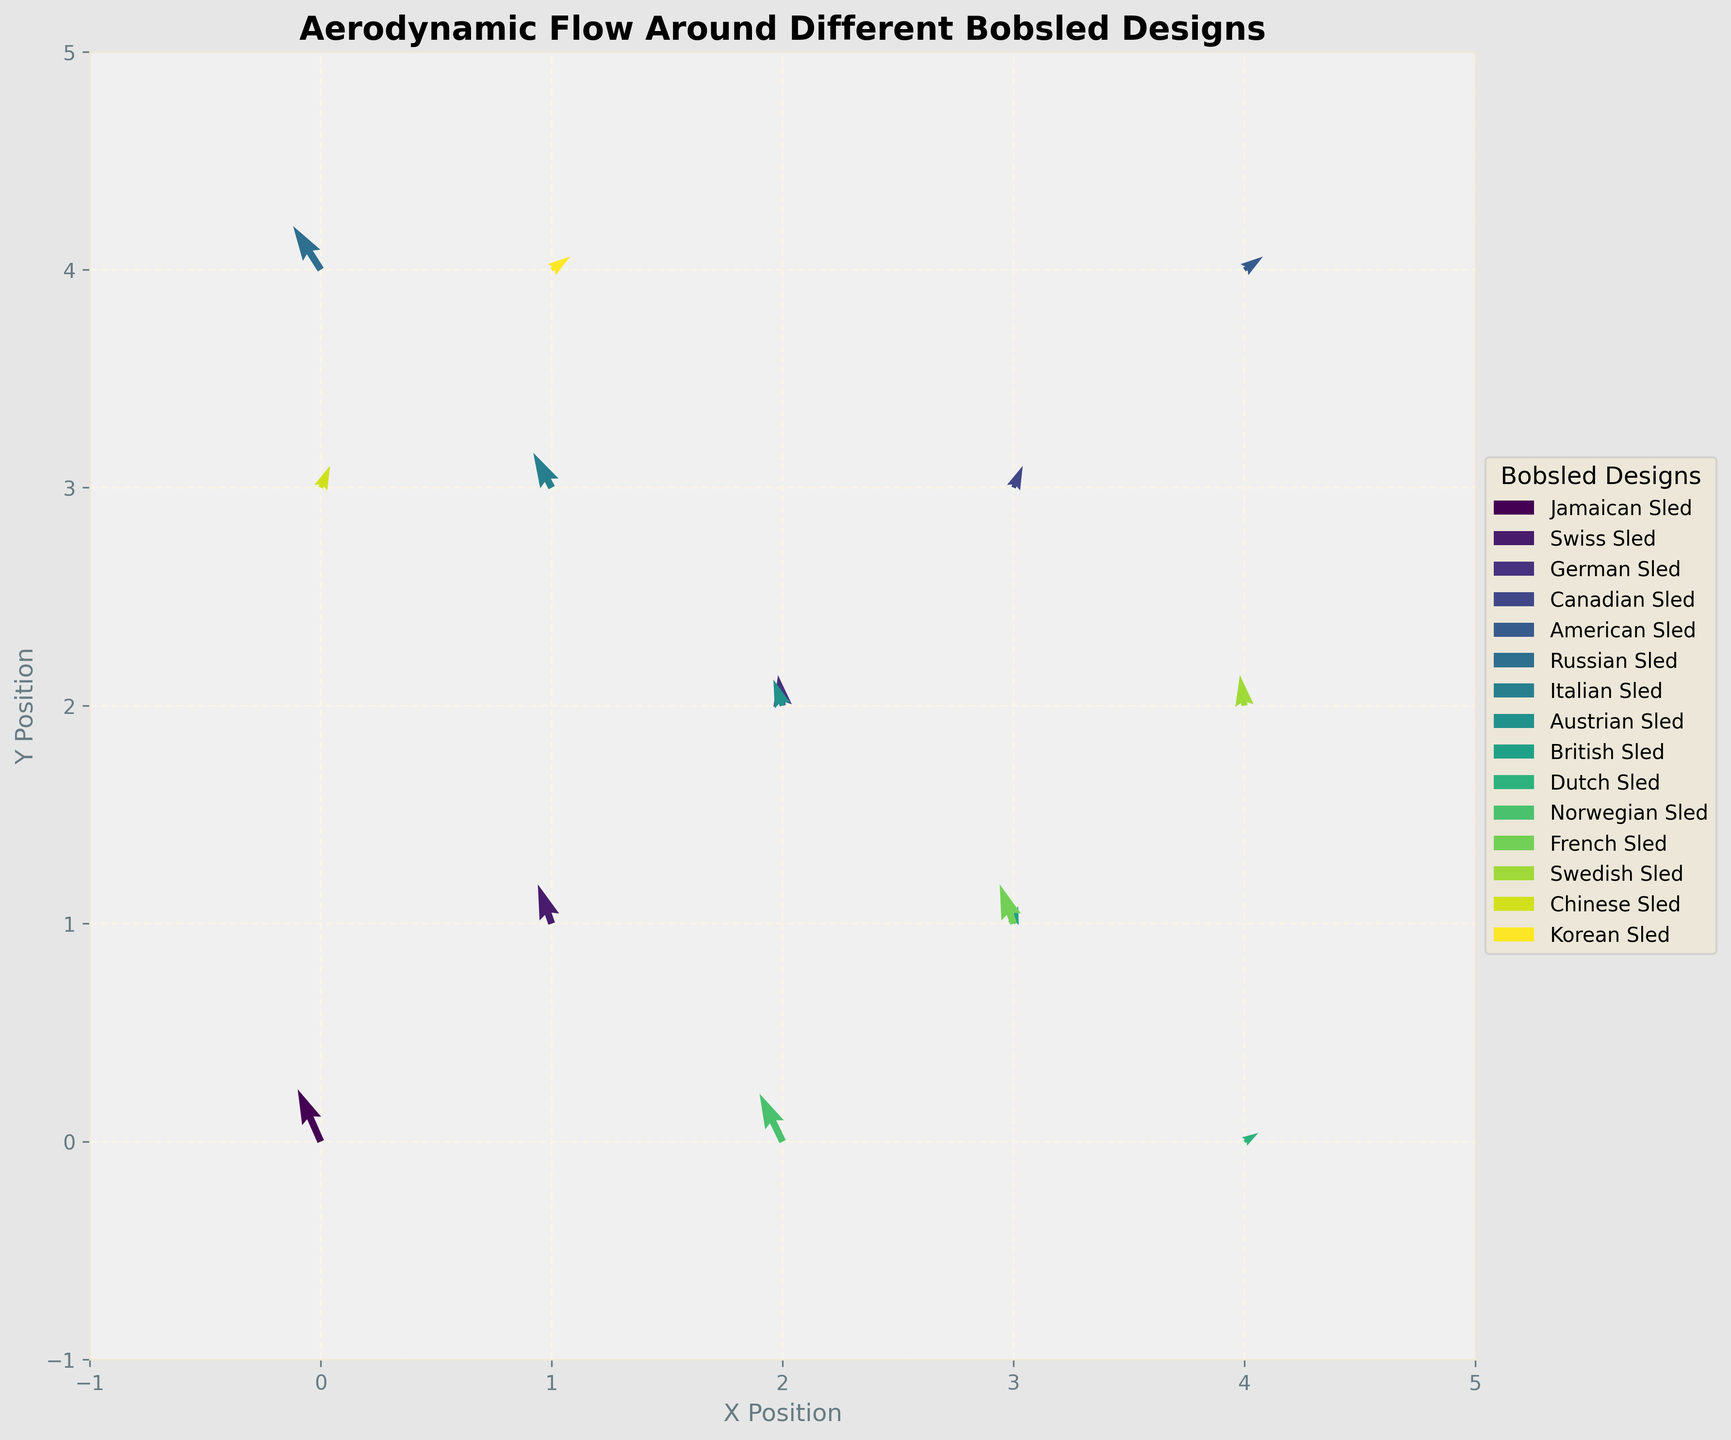What is the title of the graph? The title of the graph is typically at the top of the figure in a larger and bold font. In this case, it indicates what the entire plot is about.
Answer: Aerodynamic Flow Around Different Bobsled Designs What are the labels of the X and Y axes? These labels are usually positioned along the respective axes in a readable font. They provide context on what the values along these axes represent.
Answer: X Position, Y Position How many different bobsled designs are represented in the plot? By counting the number of unique labels in the legend, we can see how many different categories or designs are included in the plot.
Answer: 15 Which bobsled design has the vector with the highest positive X-component? To find this, we need to look at the vectors' horizontal arrows and identify which one points furthest to the right, indicating the highest X-component.
Answer: American Sled What is the general direction of flow for the Norwegian Sled? The direction of a flow for a particular sled can be determined by analyzing the corresponding vector's orientation.
Answer: Up and slightly left Which bobsled designs have vectors with a downward direction? To identify this, check which vectors point downward (negative Y-component) and then match them to the corresponding designs via the legend.
Answer: None Between the Swiss Sled and the Italian Sled, which one has a stronger flow (larger vector magnitude)? Magnitude of a vector can be calculated as the square root of (U^2 + V^2). Calculate for both and compare.
Answer: Swiss Sled Which designs have vectors originating at the same position? Look at the initial positions of the vectors (X,Y) and identify multiple designs that start from the same points.
Answer: German Sled, Austrian Sled What is the color scheme used in the plot? The color scheme is generally mentioned or can be inferred from the plot. Check the visual consistency of colors as per the colormap usage.
Answer: Viridis For the Canadian Sled, what are the components of its flow vector? This requires checking the specific vector labeled as the Canadian Sled and noting its U and V values.
Answer: U = 0.2, V = 0.5 